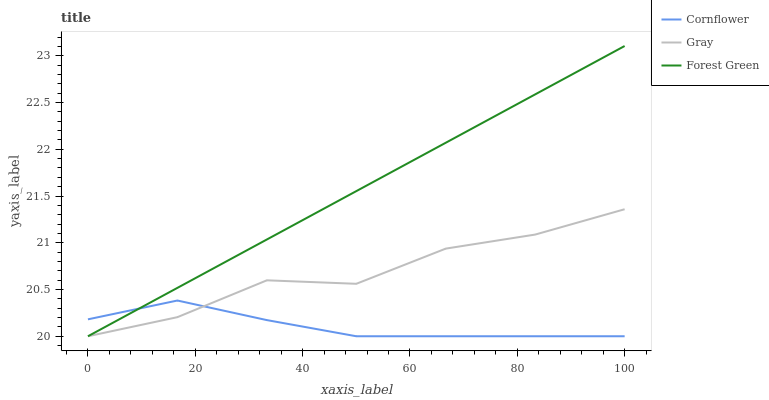Does Cornflower have the minimum area under the curve?
Answer yes or no. Yes. Does Forest Green have the maximum area under the curve?
Answer yes or no. Yes. Does Gray have the minimum area under the curve?
Answer yes or no. No. Does Gray have the maximum area under the curve?
Answer yes or no. No. Is Forest Green the smoothest?
Answer yes or no. Yes. Is Gray the roughest?
Answer yes or no. Yes. Is Gray the smoothest?
Answer yes or no. No. Is Forest Green the roughest?
Answer yes or no. No. Does Forest Green have the highest value?
Answer yes or no. Yes. Does Gray have the highest value?
Answer yes or no. No. Does Cornflower intersect Forest Green?
Answer yes or no. Yes. Is Cornflower less than Forest Green?
Answer yes or no. No. Is Cornflower greater than Forest Green?
Answer yes or no. No. 